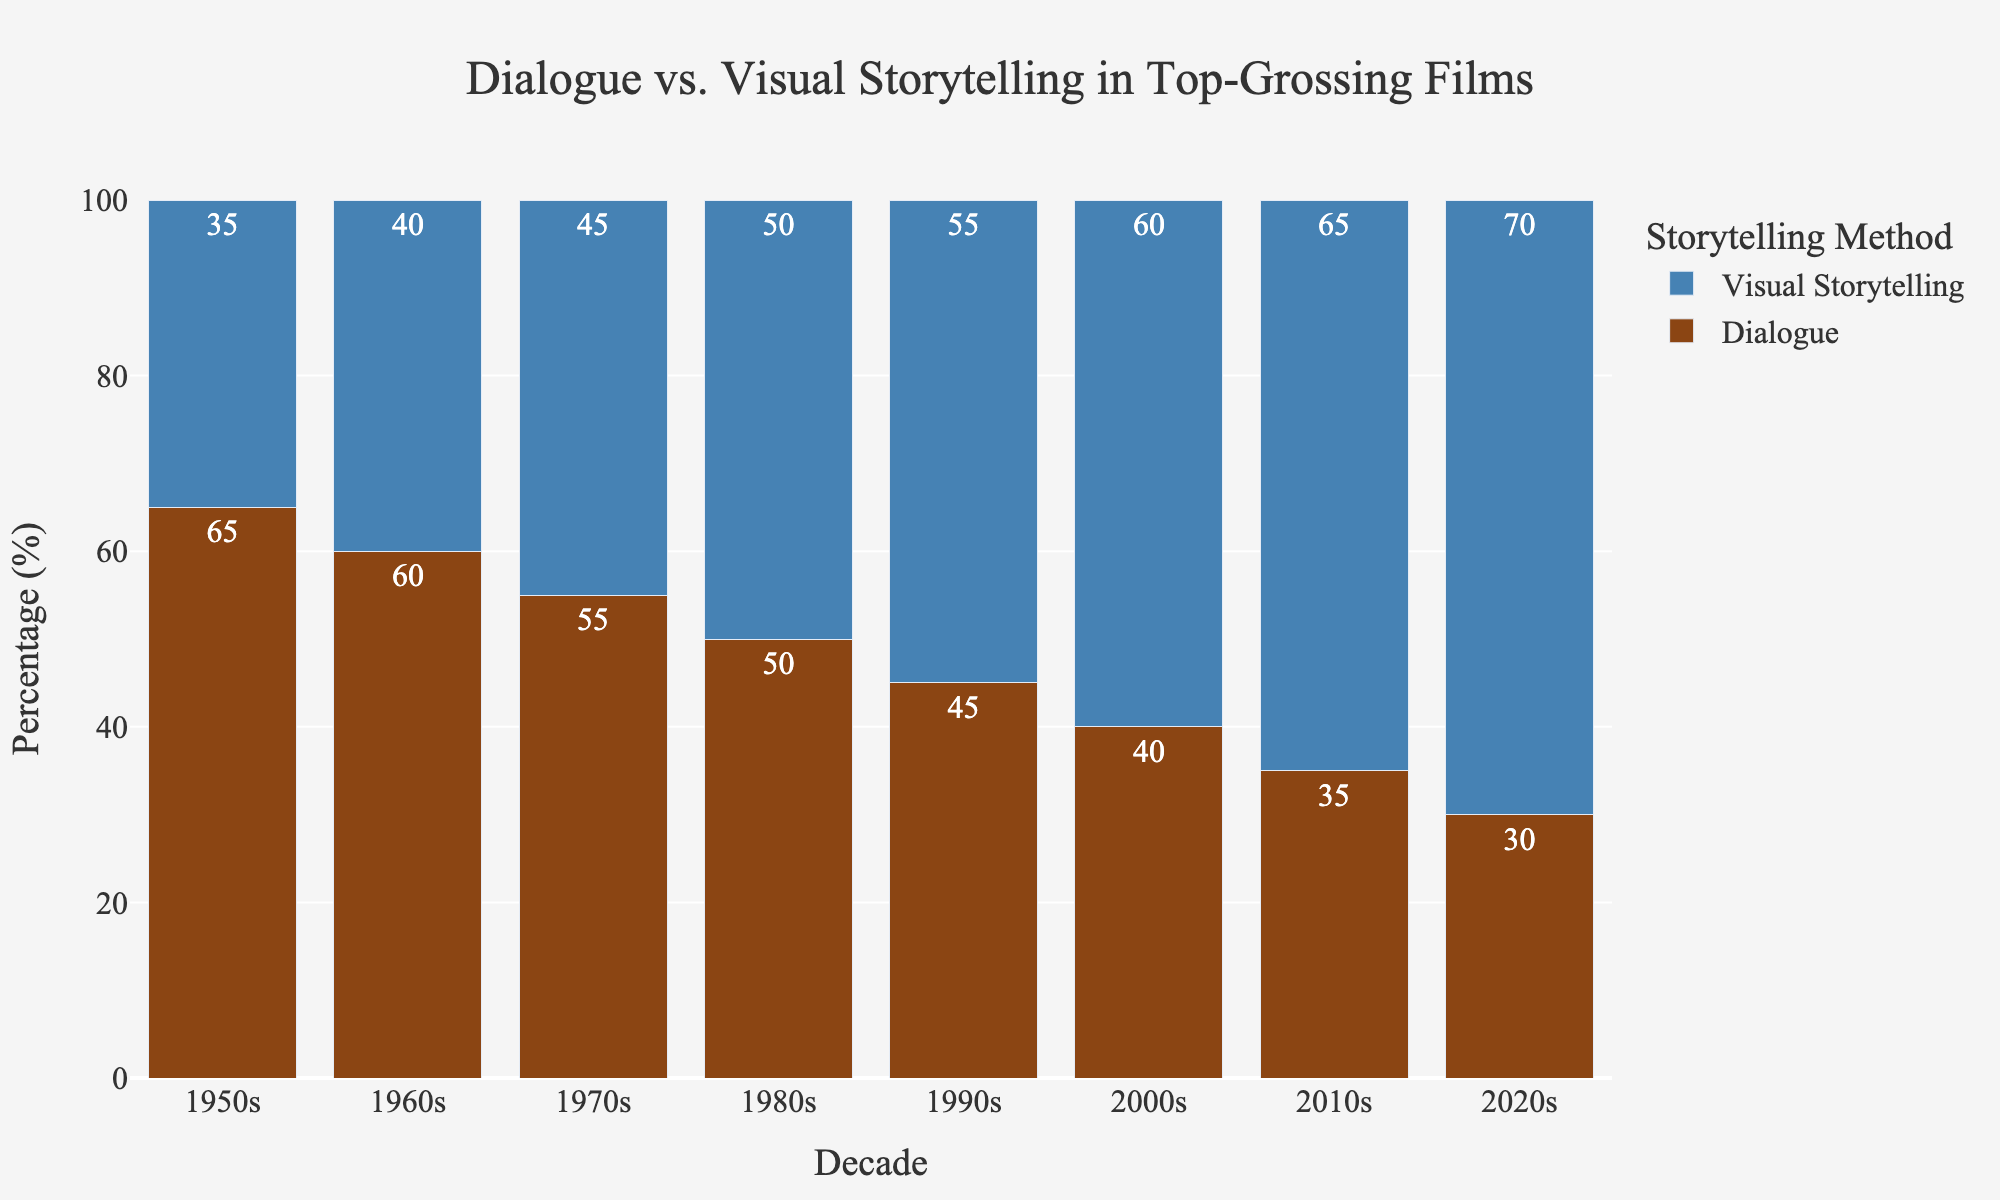What is the percentage of dialogue in the top-grossing films in the 1950s? Look at the height of the brown bar labeled "Dialogue" for the 1950s. The percentage listed is 65%.
Answer: 65% Which decade had the highest percentage of visual storytelling? Look for the decade with the tallest blue bar. The tallest blue bar represents the 2020s with 70%.
Answer: 2020s How does the percentage of dialogue in the 1980s compare to the percentage of visual storytelling in the same decade? Examine the height of both brown and blue bars for the 1980s. Both bars have the same height, representing 50%.
Answer: They are equal What is the sum of the percentages of dialogue and visual storytelling in the 1990s? Add the percentage values of the brown bar (45%) and the blue bar (55%) for the 1990s. 45 + 55 = 100.
Answer: 100 What trend is visible from the 1950s to the 2020s regarding dialogue and visual storytelling? Observe the changes in the heights of the brown and blue bars across the decades. The percentage of dialogue decreases while the percentage of visual storytelling increases.
Answer: Dialogue decreases; visual storytelling increases By how much did the percentage of visual storytelling increase from the 1950s to the 2020s? Subtract the percentage value of visual storytelling in the 1950s (35%) from that in the 2020s (70%). 70 - 35 = 35.
Answer: 35% What is the average percentage of dialogue across all the decades? Add the dialogue percentages for all decades and divide by the number of decades. (65 + 60 + 55 + 50 + 45 + 40 + 35 + 30) / 8 = 47.5.
Answer: 47.5% Which decade shows an equal percentage of dialogue and visual storytelling? Look for the decade where the heights of the brown and blue bars are the same. In the 1980s, both percentages are 50%.
Answer: 1980s What is the difference in the percentage of dialogue between the 1950s and the 2000s? Subtract the percentage of dialogue in the 2000s (40%) from that in the 1950s (65%). 65 - 40 = 25.
Answer: 25 How does the visual storytelling percentage in the 2010s compare to the dialogue percentage in the same decade? Check the heights of the blue (65%) and brown (35%) bars for the 2010s. The blue bar is 30% higher than the brown bar.
Answer: 30% higher 